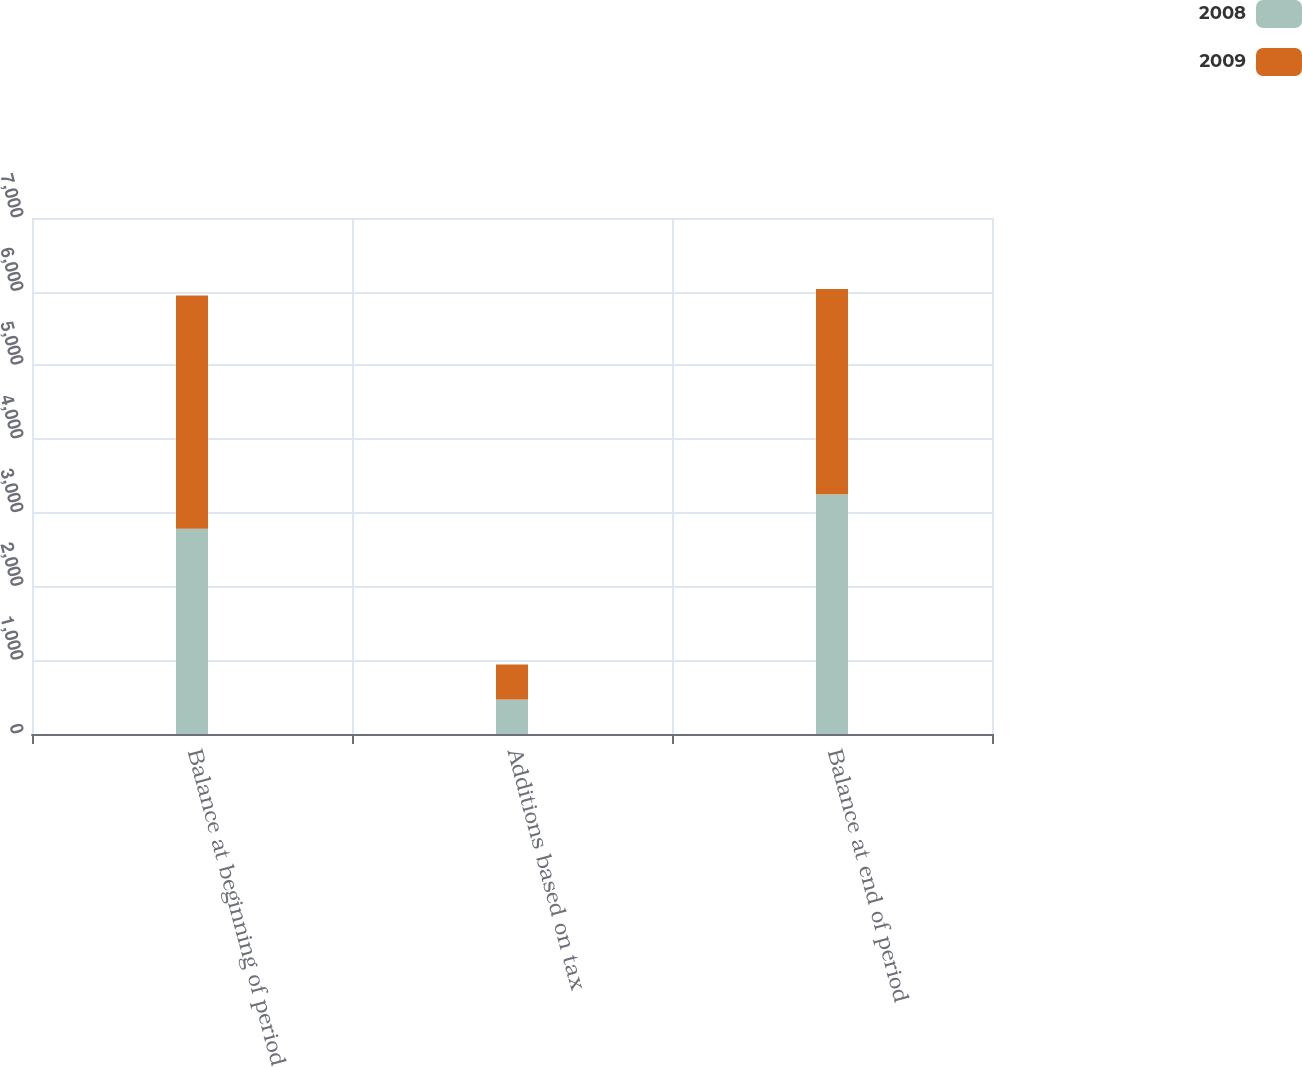Convert chart. <chart><loc_0><loc_0><loc_500><loc_500><stacked_bar_chart><ecel><fcel>Balance at beginning of period<fcel>Additions based on tax<fcel>Balance at end of period<nl><fcel>2008<fcel>2784<fcel>469<fcel>3253<nl><fcel>2009<fcel>3166<fcel>474<fcel>2784<nl></chart> 